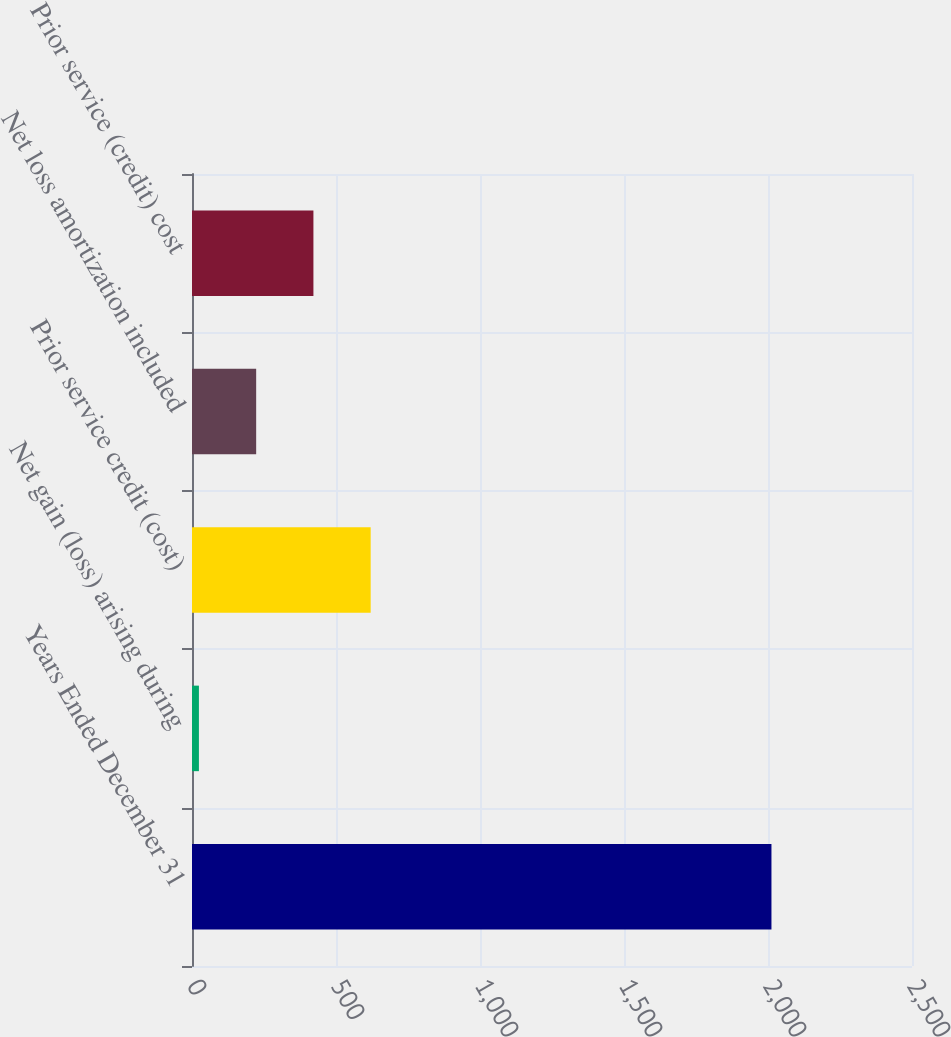Convert chart to OTSL. <chart><loc_0><loc_0><loc_500><loc_500><bar_chart><fcel>Years Ended December 31<fcel>Net gain (loss) arising during<fcel>Prior service credit (cost)<fcel>Net loss amortization included<fcel>Prior service (credit) cost<nl><fcel>2012<fcel>24<fcel>620.4<fcel>222.8<fcel>421.6<nl></chart> 